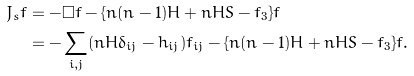Convert formula to latex. <formula><loc_0><loc_0><loc_500><loc_500>J _ { s } f & = - \Box f - \{ n ( n - 1 ) H + n H S - f _ { 3 } \} f \\ & = - \sum _ { i , j } ( n H \delta _ { i j } - h _ { i j } ) f _ { i j } - \{ n ( n - 1 ) H + n H S - f _ { 3 } \} f .</formula> 